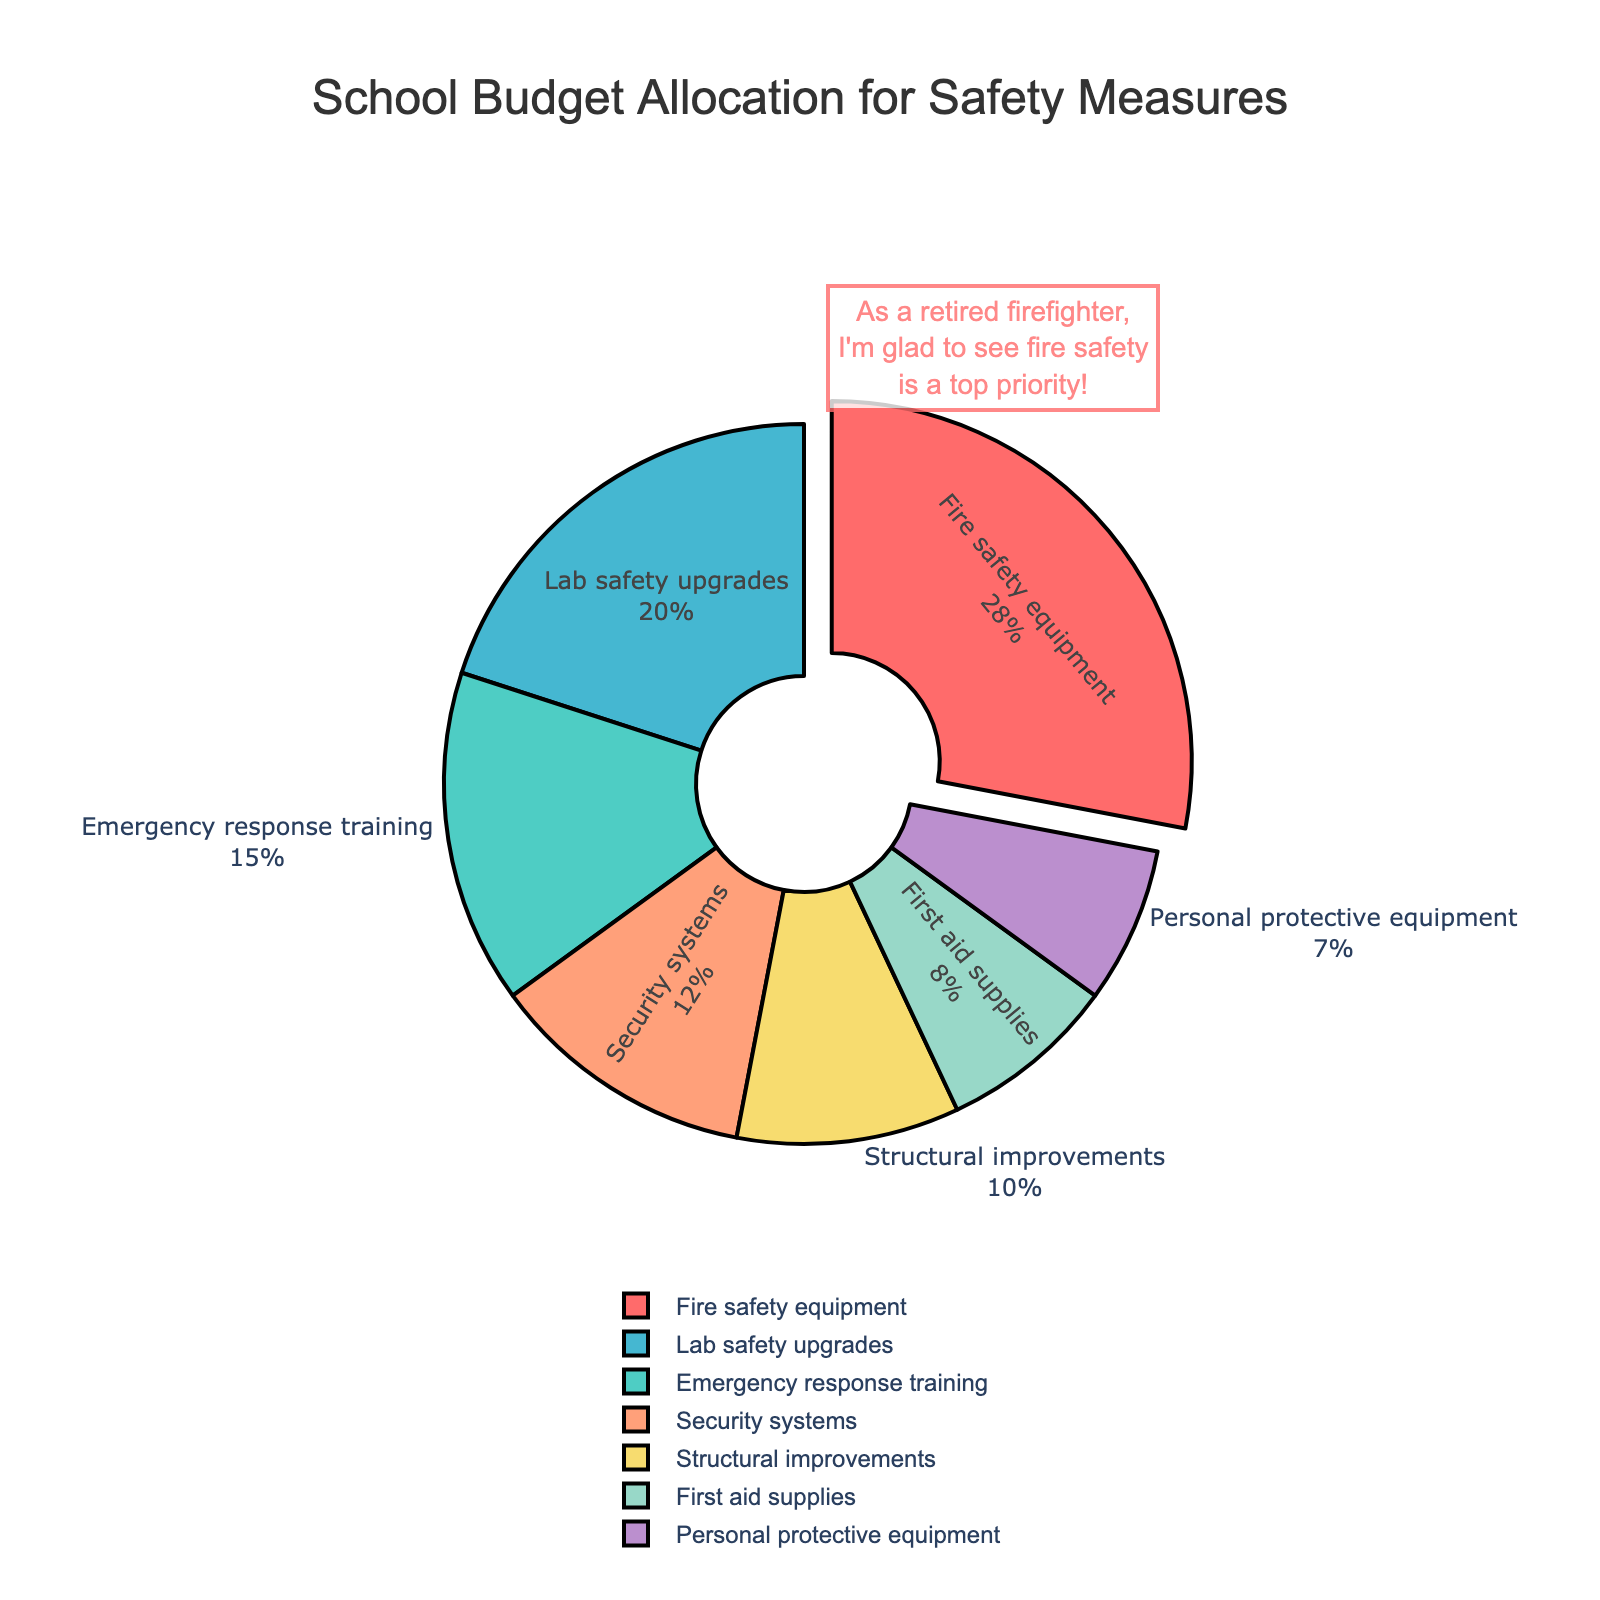Which category gets the largest portion of the school safety budget? The figure shows that the fire safety equipment category is visually emphasized and has the largest represented portion on the pie chart.
Answer: Fire safety equipment What percentage of the budget goes to emergency response training? Referring to the pie chart, the emergency response training segment is labeled with a specific percentage.
Answer: 15% Is the budget allocation for structural improvements greater than for first aid supplies? By comparing the sizes and labels of the corresponding segments on the pie chart, we can see that structural improvements have a higher percentage allocation compared to first aid supplies.
Answer: Yes How does the budget for lab safety upgrades compare to that for security systems and personal protective equipment combined? Lab safety upgrades are 20%, and combining the percentages for security systems (12%) and personal protective equipment (7%) gives 19%. So, lab safety upgrades have a slightly higher budget allocation.
Answer: Lab safety upgrades are greater What is the combined percentage of the budget allocated to non-fire safety categories? By summing the percentages of all categories except fire safety equipment (15% + 20% + 12% + 8% + 10% + 7%), the total is 72%.
Answer: 72% What percentage of the budget is allocated to categories related to immediate emergency response (emergency response training and first aid supplies)? By adding the percentages of emergency response training (15%) and first aid supplies (8%), the total allocation is 23%.
Answer: 23% Which category is highlighted with a slight pull away from the rest of the pie chart? Observing the visual pull in the pie chart, the fire safety equipment slice is pulled away, indicating its emphasis.
Answer: Fire safety equipment Is the percentage of the budget spent on lab safety upgrades closer to that of structural improvements or security systems? Comparing the percentages, lab safety upgrades (20%) is closer to structural improvements (10%) than to security systems (12%).
Answer: Security systems What categories collectively represent less than 20% of the budget? Personal protective equipment (7%) and first aid supplies (8%) both represent less than 20% of the budget individually.
Answer: Personal protective equipment, First aid supplies By visually inspecting the chart, which two budget categories have nearly similar allocations? Observing the chart, security systems (12%) and structural improvements (10%) have nearly similar percentages.
Answer: Security systems, Structural improvements 